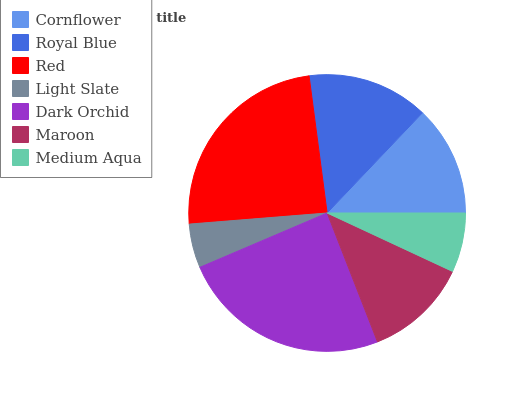Is Light Slate the minimum?
Answer yes or no. Yes. Is Dark Orchid the maximum?
Answer yes or no. Yes. Is Royal Blue the minimum?
Answer yes or no. No. Is Royal Blue the maximum?
Answer yes or no. No. Is Royal Blue greater than Cornflower?
Answer yes or no. Yes. Is Cornflower less than Royal Blue?
Answer yes or no. Yes. Is Cornflower greater than Royal Blue?
Answer yes or no. No. Is Royal Blue less than Cornflower?
Answer yes or no. No. Is Cornflower the high median?
Answer yes or no. Yes. Is Cornflower the low median?
Answer yes or no. Yes. Is Maroon the high median?
Answer yes or no. No. Is Maroon the low median?
Answer yes or no. No. 